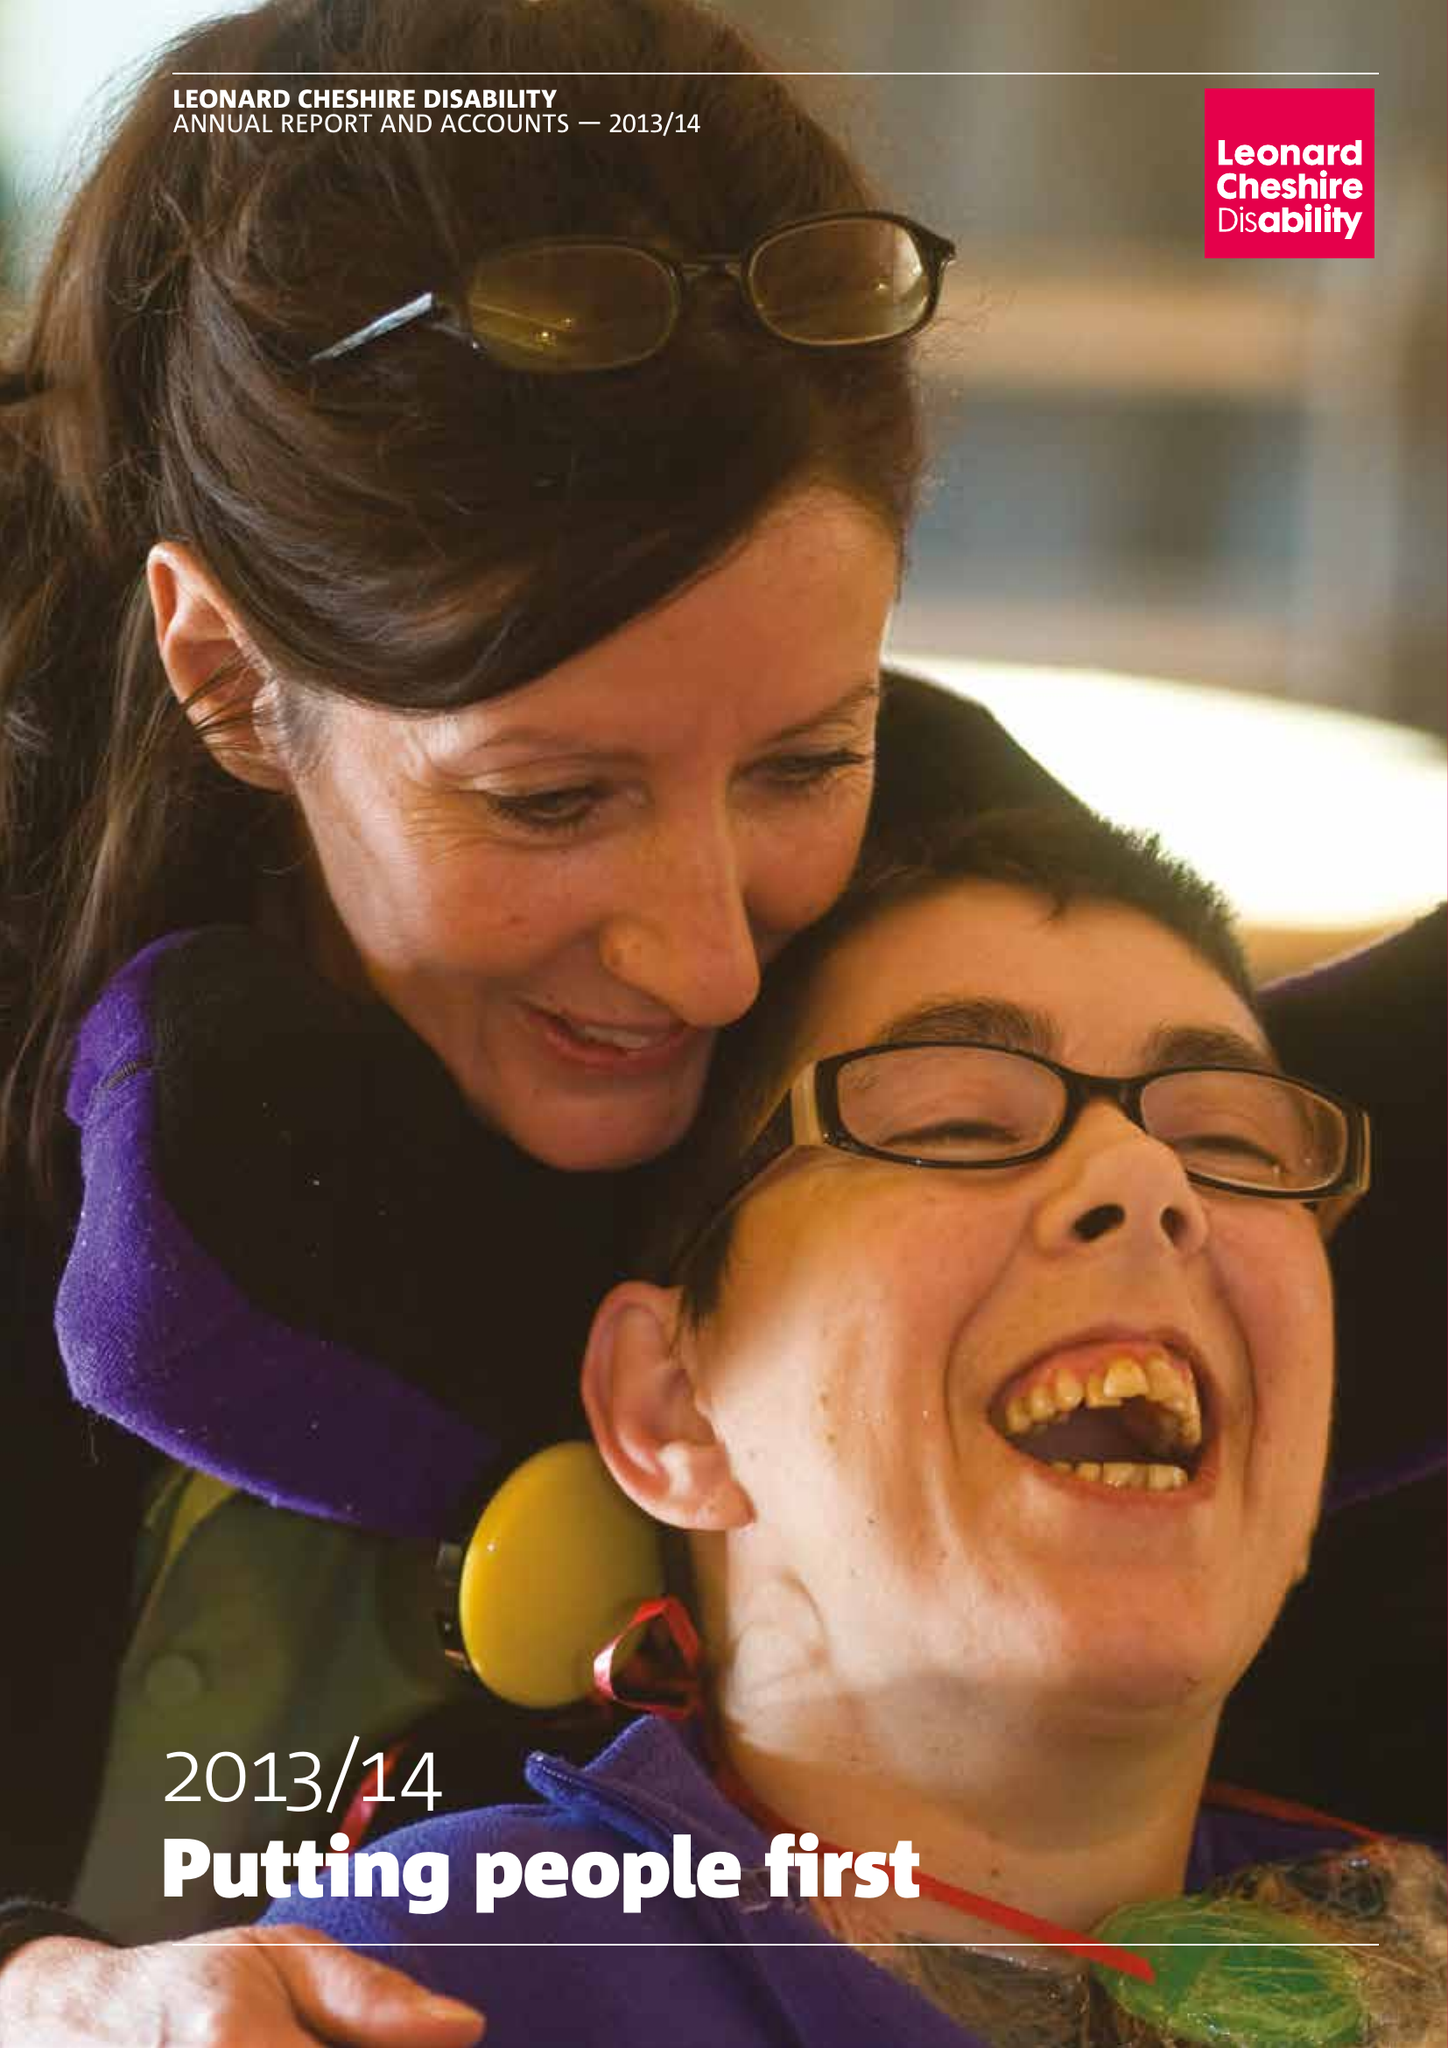What is the value for the charity_number?
Answer the question using a single word or phrase. 218186 